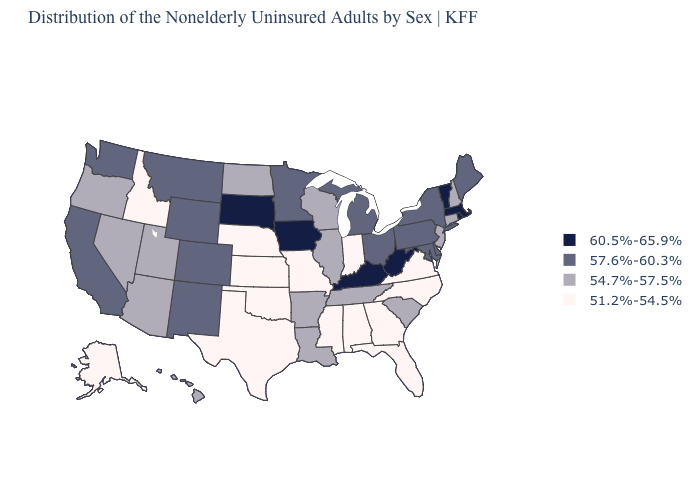What is the lowest value in the USA?
Short answer required. 51.2%-54.5%. What is the value of South Dakota?
Answer briefly. 60.5%-65.9%. What is the value of Texas?
Be succinct. 51.2%-54.5%. Name the states that have a value in the range 60.5%-65.9%?
Keep it brief. Iowa, Kentucky, Massachusetts, Rhode Island, South Dakota, Vermont, West Virginia. Name the states that have a value in the range 60.5%-65.9%?
Be succinct. Iowa, Kentucky, Massachusetts, Rhode Island, South Dakota, Vermont, West Virginia. What is the highest value in the USA?
Keep it brief. 60.5%-65.9%. What is the value of New Jersey?
Answer briefly. 54.7%-57.5%. What is the value of Washington?
Answer briefly. 57.6%-60.3%. What is the value of Oregon?
Concise answer only. 54.7%-57.5%. Among the states that border New Hampshire , which have the highest value?
Concise answer only. Massachusetts, Vermont. Name the states that have a value in the range 60.5%-65.9%?
Keep it brief. Iowa, Kentucky, Massachusetts, Rhode Island, South Dakota, Vermont, West Virginia. What is the value of Kentucky?
Quick response, please. 60.5%-65.9%. Among the states that border Montana , which have the lowest value?
Write a very short answer. Idaho. What is the value of Nebraska?
Concise answer only. 51.2%-54.5%. What is the highest value in the MidWest ?
Give a very brief answer. 60.5%-65.9%. 